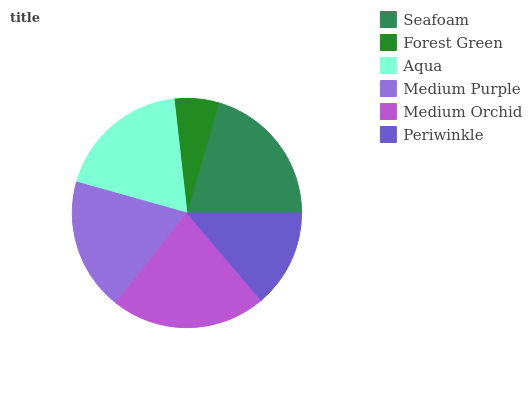Is Forest Green the minimum?
Answer yes or no. Yes. Is Medium Orchid the maximum?
Answer yes or no. Yes. Is Aqua the minimum?
Answer yes or no. No. Is Aqua the maximum?
Answer yes or no. No. Is Aqua greater than Forest Green?
Answer yes or no. Yes. Is Forest Green less than Aqua?
Answer yes or no. Yes. Is Forest Green greater than Aqua?
Answer yes or no. No. Is Aqua less than Forest Green?
Answer yes or no. No. Is Aqua the high median?
Answer yes or no. Yes. Is Medium Purple the low median?
Answer yes or no. Yes. Is Medium Purple the high median?
Answer yes or no. No. Is Periwinkle the low median?
Answer yes or no. No. 